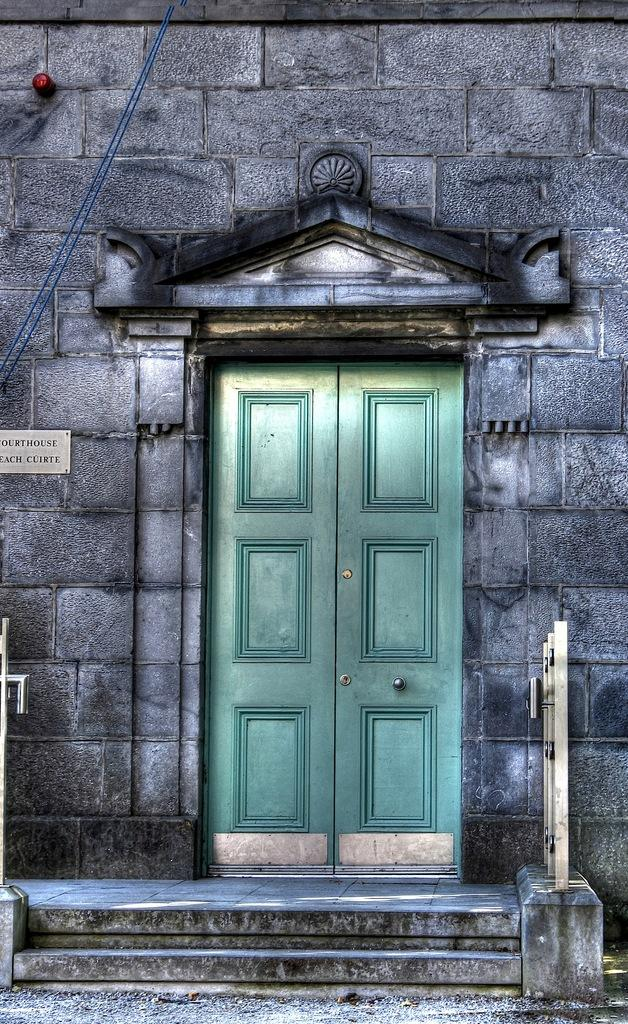What type of entrance can be seen in the image? There is a door in the image. What is located near the door? There is a metal fence in the image. Are there any architectural features visible in the image? Yes, there are stairs in the image. What can be seen on a wall in the image? There is a name board on a wall in the image. What else is visible in the image? There are wires visible in the image. What type of pin can be seen on the name board in the image? There is no pin visible on the name board in the image. What decision is being made in the image? There is no indication of a decision being made in the image. 